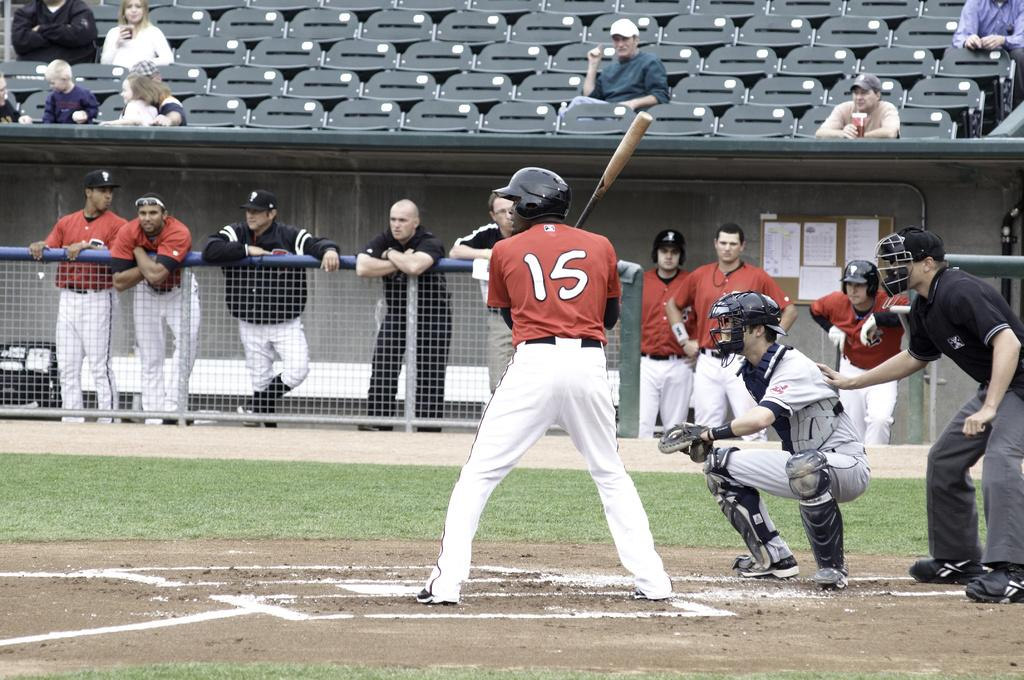<image>
Present a compact description of the photo's key features. a person with a red jersey that has the number 15 on it 